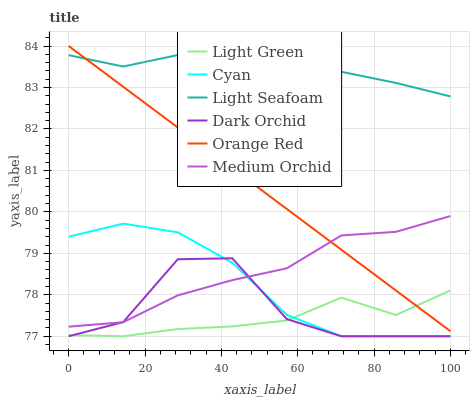Does Light Green have the minimum area under the curve?
Answer yes or no. Yes. Does Light Seafoam have the maximum area under the curve?
Answer yes or no. Yes. Does Dark Orchid have the minimum area under the curve?
Answer yes or no. No. Does Dark Orchid have the maximum area under the curve?
Answer yes or no. No. Is Orange Red the smoothest?
Answer yes or no. Yes. Is Dark Orchid the roughest?
Answer yes or no. Yes. Is Light Green the smoothest?
Answer yes or no. No. Is Light Green the roughest?
Answer yes or no. No. Does Dark Orchid have the lowest value?
Answer yes or no. Yes. Does Light Seafoam have the lowest value?
Answer yes or no. No. Does Orange Red have the highest value?
Answer yes or no. Yes. Does Dark Orchid have the highest value?
Answer yes or no. No. Is Medium Orchid less than Light Seafoam?
Answer yes or no. Yes. Is Medium Orchid greater than Light Green?
Answer yes or no. Yes. Does Cyan intersect Medium Orchid?
Answer yes or no. Yes. Is Cyan less than Medium Orchid?
Answer yes or no. No. Is Cyan greater than Medium Orchid?
Answer yes or no. No. Does Medium Orchid intersect Light Seafoam?
Answer yes or no. No. 